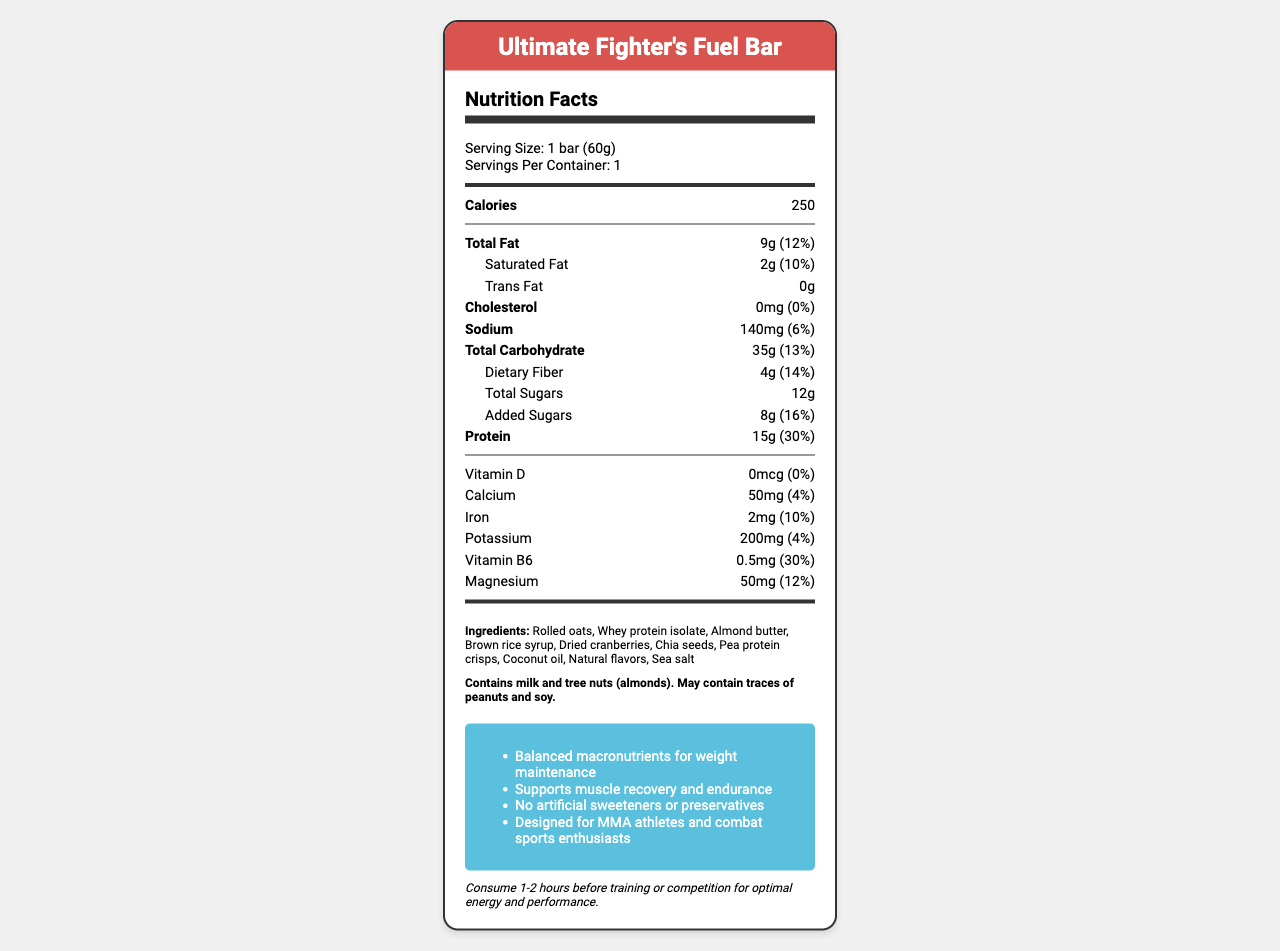what is the serving size of the product? The serving size is indicated as "1 bar (60g)" in the serving info section at the top of the document.
Answer: 1 bar (60g) how many grams of protein are in one bar? The amount of protein is listed as "15g" under the nutrient row for Protein.
Answer: 15g what is the percent daily value of dietary fiber in the bar? The percent daily value of dietary fiber is shown as "14%" in the nutrient row for Dietary Fiber.
Answer: 14% which ingredients may cause allergic reactions? The allergen information section explicitly states that the product contains milk and tree nuts (almonds).
Answer: milk and tree nuts (almonds) how much calcium does the bar provide? The amount of calcium is listed as "50mg" under the nutrient row for Calcium.
Answer: 50mg which nutrient has the highest percent daily value? A. Vitamin D B. Protein C. Iron D. Vitamin B6 The percent daily value of nutrients is indicated in parentheses. Protein has a 30% daily value, higher than Vitamin D (0%), Iron (10%), and Vitamin B6 (30%).
Answer: B how many grams of added sugars are in the bar? A. 4g B. 8g C. 12g D. 15g The amount of added sugars is shown as "8g" under the nutrient row for Added Sugars.
Answer: B is there any trans fat in the bar? The amount of trans fat is listed as "0g" under the sub-nutrient row for Trans Fat.
Answer: No does the bar contain any artificial sweeteners or preservatives? One of the product claims states "No artificial sweeteners or preservatives."
Answer: No what are the main goals of the product according to its claims? The product claims listed in the document highlight these goals.
Answer: Balanced macronutrients for weight maintenance, supports muscle recovery and endurance, designed for MMA athletes and combat sports enthusiasts does the bar meet the daily requirement of Vitamin D? The Vitamin D amount is 0mcg with a percent daily value of 0%, indicating it does not contribute to the daily requirement.
Answer: No how often should the bar be consumed before training or competition? The usage instructions state that the bar should be consumed 1-2 hours before training or competition.
Answer: 1-2 hours before what is the highest amount of any vitamin or mineral in the bar? The document shows the potassium amount as 200mg, the highest among listed vitamins and minerals.
Answer: Potassium, 200mg which ingredient is likely the primary protein source? Whey protein isolate is listed among the ingredients and commonly used as a primary protein source.
Answer: Whey protein isolate what are the total calories from fat in the bar? The document provides total fat grams and calories but does not specify the calories derived specifically from fat.
Answer: Cannot be determined describe the detailed nutritional information provided for "Ultimate Fighter's Fuel Bar". The document is presented visually, featuring sections for serving size, calories, nutrients, ingredients, allergen info, product claims, and usage instructions.
Answer: The document provides detailed nutritional information for "Ultimate Fighter's Fuel Bar," including serving size, calories, and amounts of various nutrients such as total fat, saturated fat, trans fat, cholesterol, sodium, total carbohydrates, dietary fiber, total sugars, added sugars, protein, vitamins, and minerals. It also lists ingredients, allergen information, product claims, and usage instructions. 